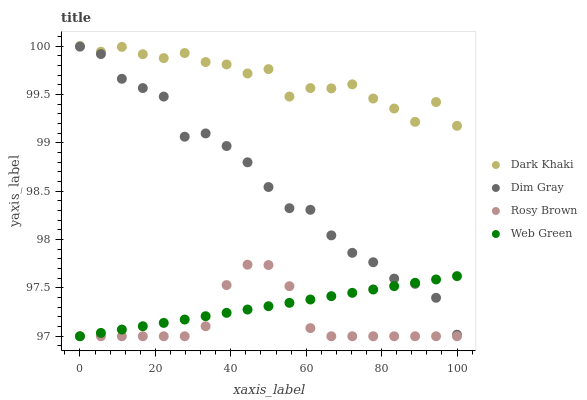Does Rosy Brown have the minimum area under the curve?
Answer yes or no. Yes. Does Dark Khaki have the maximum area under the curve?
Answer yes or no. Yes. Does Dim Gray have the minimum area under the curve?
Answer yes or no. No. Does Dim Gray have the maximum area under the curve?
Answer yes or no. No. Is Web Green the smoothest?
Answer yes or no. Yes. Is Dark Khaki the roughest?
Answer yes or no. Yes. Is Rosy Brown the smoothest?
Answer yes or no. No. Is Rosy Brown the roughest?
Answer yes or no. No. Does Rosy Brown have the lowest value?
Answer yes or no. Yes. Does Dim Gray have the lowest value?
Answer yes or no. No. Does Dark Khaki have the highest value?
Answer yes or no. Yes. Does Rosy Brown have the highest value?
Answer yes or no. No. Is Rosy Brown less than Dark Khaki?
Answer yes or no. Yes. Is Dark Khaki greater than Web Green?
Answer yes or no. Yes. Does Web Green intersect Dim Gray?
Answer yes or no. Yes. Is Web Green less than Dim Gray?
Answer yes or no. No. Is Web Green greater than Dim Gray?
Answer yes or no. No. Does Rosy Brown intersect Dark Khaki?
Answer yes or no. No. 